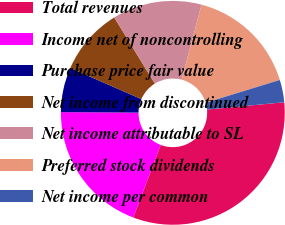Convert chart. <chart><loc_0><loc_0><loc_500><loc_500><pie_chart><fcel>Total revenues<fcel>Income net of noncontrolling<fcel>Purchase price fair value<fcel>Net income from discontinued<fcel>Net income attributable to SL<fcel>Preferred stock dividends<fcel>Net income per common<nl><fcel>32.26%<fcel>19.35%<fcel>6.45%<fcel>9.68%<fcel>12.9%<fcel>16.13%<fcel>3.23%<nl></chart> 